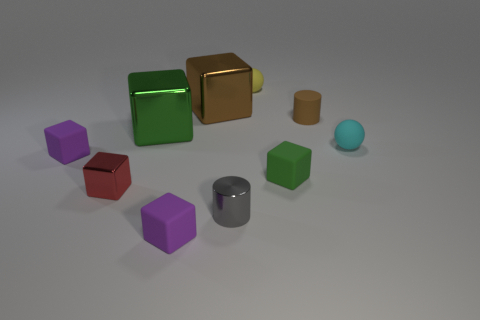Subtract 2 cubes. How many cubes are left? 4 Subtract all tiny purple matte cubes. How many cubes are left? 4 Subtract all brown blocks. How many blocks are left? 5 Subtract all gray blocks. Subtract all red spheres. How many blocks are left? 6 Subtract all large gray metallic cylinders. Subtract all small red shiny things. How many objects are left? 9 Add 9 yellow balls. How many yellow balls are left? 10 Add 1 brown things. How many brown things exist? 3 Subtract 2 green blocks. How many objects are left? 8 Subtract all spheres. How many objects are left? 8 